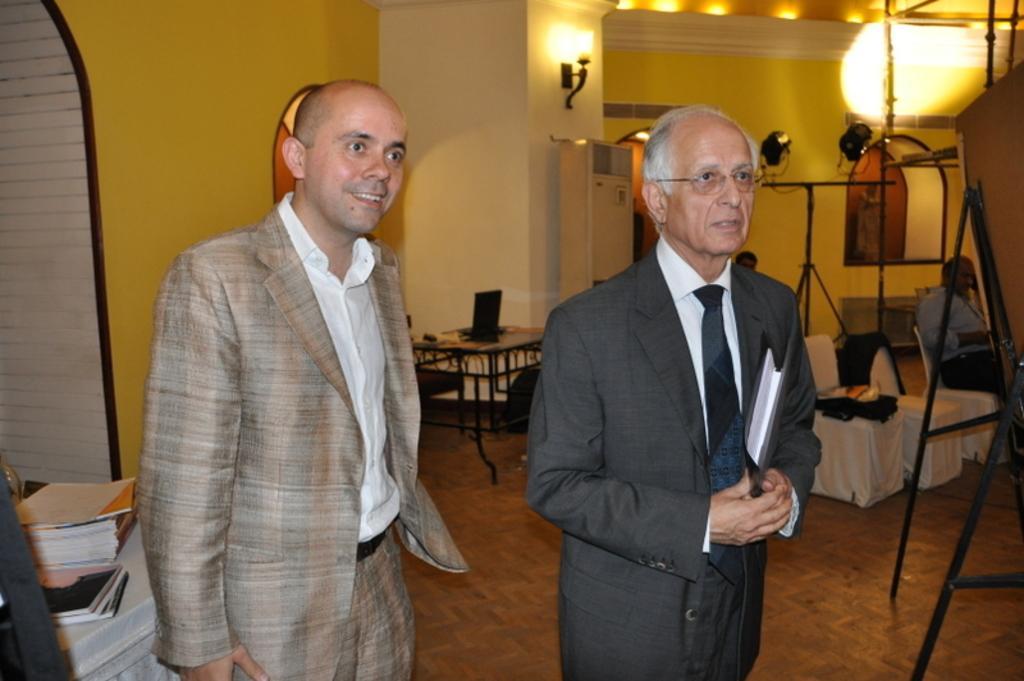Please provide a concise description of this image. In this picture we can see two persons standing on the floor. These are the chairs and this is table. Here we can see some books. On the background there is a wall. And these are the lights. And this is floor. 